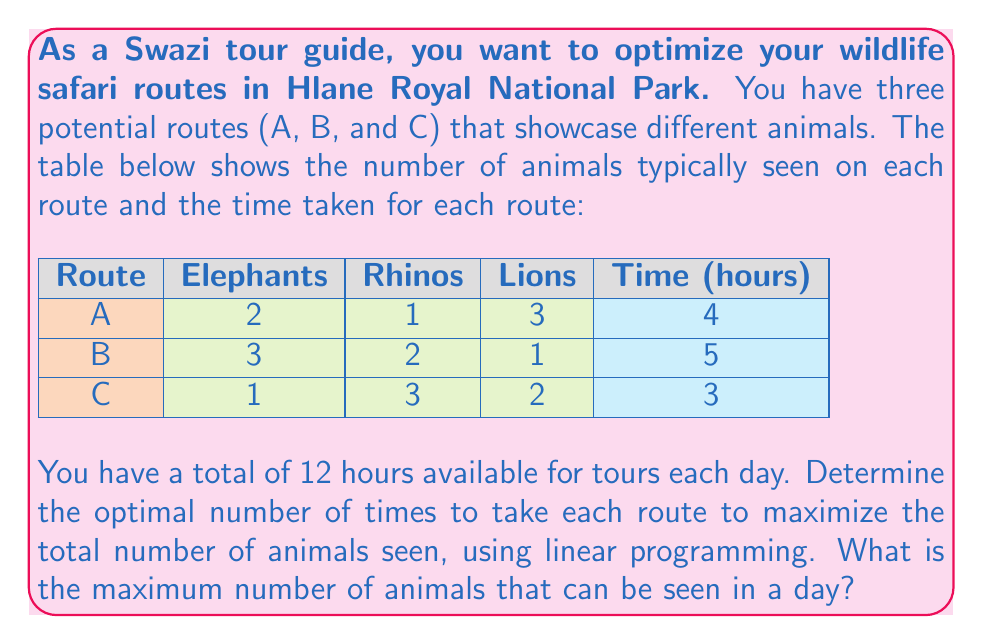What is the answer to this math problem? Let's approach this step-by-step using linear programming:

1) Define variables:
   Let $x$, $y$, and $z$ be the number of times routes A, B, and C are taken, respectively.

2) Objective function:
   We want to maximize the total number of animals seen:
   $$ \text{Maximize } 6x + 6y + 6z $$
   (2+1+3)x + (3+2+1)y + (1+3+2)z = 6x + 6y + 6z

3) Constraints:
   Time constraint: $4x + 5y + 3z \leq 12$ (total time ≤ 12 hours)
   Non-negativity: $x, y, z \geq 0$ and integers

4) Set up the linear program:
   $$ \begin{align*}
   \text{Maximize: } & 6x + 6y + 6z \\
   \text{Subject to: } & 4x + 5y + 3z \leq 12 \\
   & x, y, z \geq 0 \text{ and integers}
   \end{align*} $$

5) Solve using the simplex method or a solver. The optimal solution is:
   $x = 0, y = 0, z = 4$

6) Calculate the maximum number of animals seen:
   $6(0) + 6(0) + 6(4) = 24$

Therefore, the optimal strategy is to take route C four times, which allows for seeing a maximum of 24 animals in a day.
Answer: 24 animals 